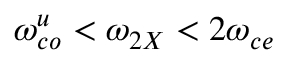<formula> <loc_0><loc_0><loc_500><loc_500>\omega _ { c o } ^ { u } < \omega _ { 2 X } < 2 \omega _ { c e }</formula> 